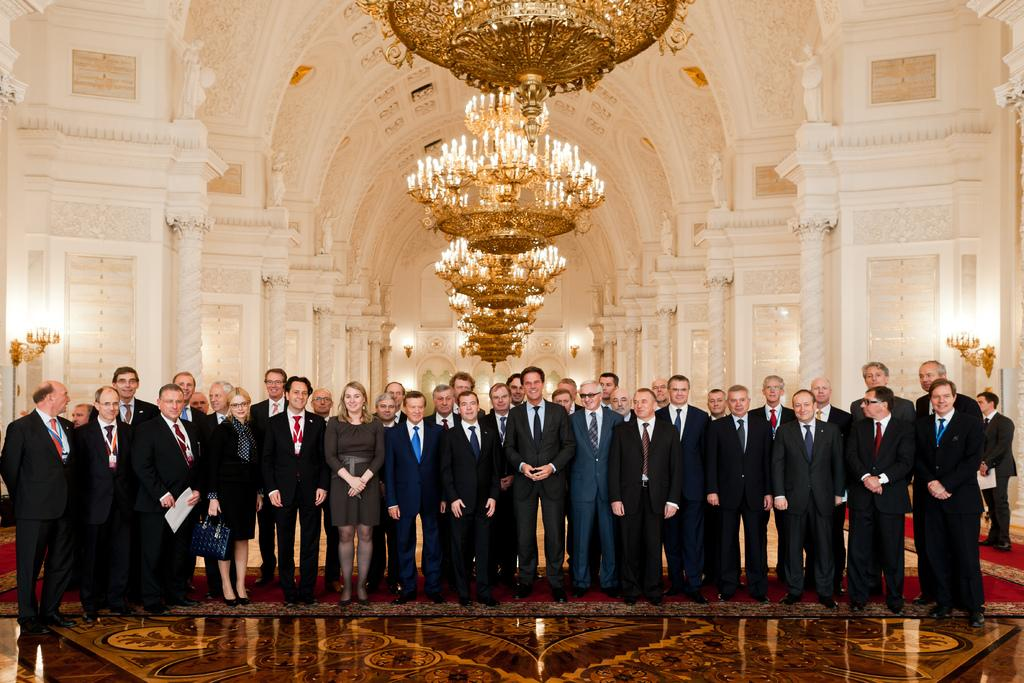What is happening with the group of people in the image? The group of people are posing for a photograph. What can be seen in the background of the image? There are beautiful pillars in the background of the image. What is hanging from the ceiling in the image? There are chandeliers at the top of the image. What type of mark can be seen on the hospital floor in the image? There is no hospital or mark present in the image; it features a group of people posing for a photograph with beautiful pillars and chandeliers in the background. 